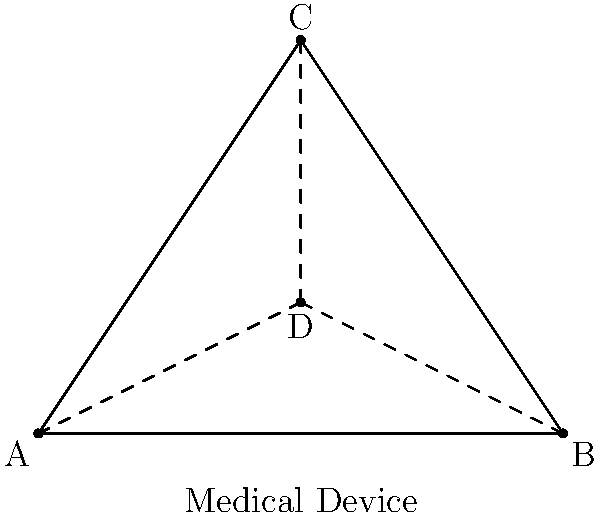In a triangular room setup for a patient, medical devices are placed at points A, B, and C, forming an equilateral triangle. A central access point D is located at the centroid of the triangle. How many rotational symmetries does this arrangement have? To determine the number of rotational symmetries in this arrangement, we need to follow these steps:

1) First, recognize that the medical devices form an equilateral triangle. An equilateral triangle has three vertices and three equal sides.

2) The central access point D is located at the centroid of the triangle, which is the point where the medians intersect. This point is equidistant from all three vertices.

3) Rotational symmetry occurs when an object can be rotated around a fixed point and appear unchanged.

4) For an equilateral triangle:
   - A 120° rotation ($$\frac{2\pi}{3}$$ radians) will bring the triangle back to its original position.
   - A 240° rotation ($$\frac{4\pi}{3}$$ radians) will also bring the triangle back to its original position.
   - A 360° rotation ($$2\pi$$ radians) is a full rotation, returning to the starting position.

5) Therefore, there are three distinct rotations (including the identity rotation of 0° or 360°) that will leave the arrangement looking the same.

Thus, this arrangement has 3 rotational symmetries.
Answer: 3 